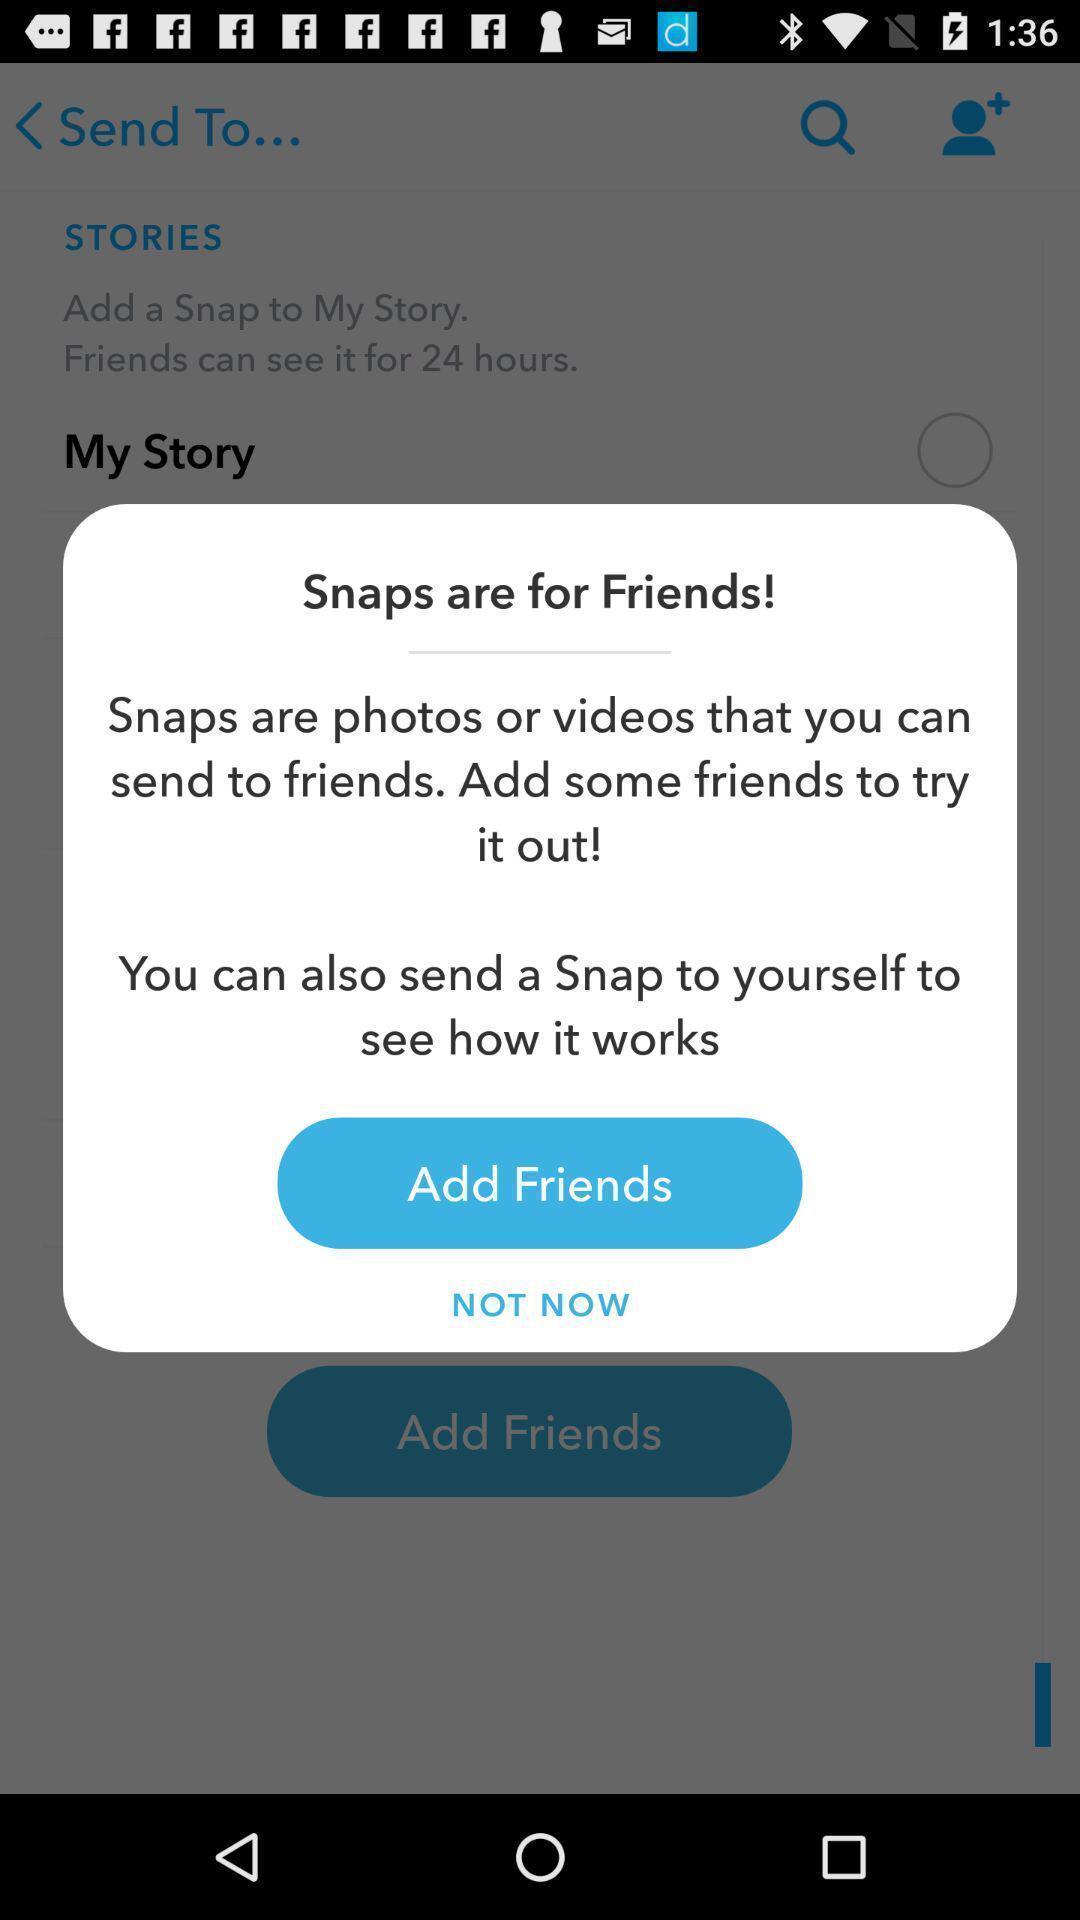What is the overall content of this screenshot? Popup showing displaying option to add friends. 